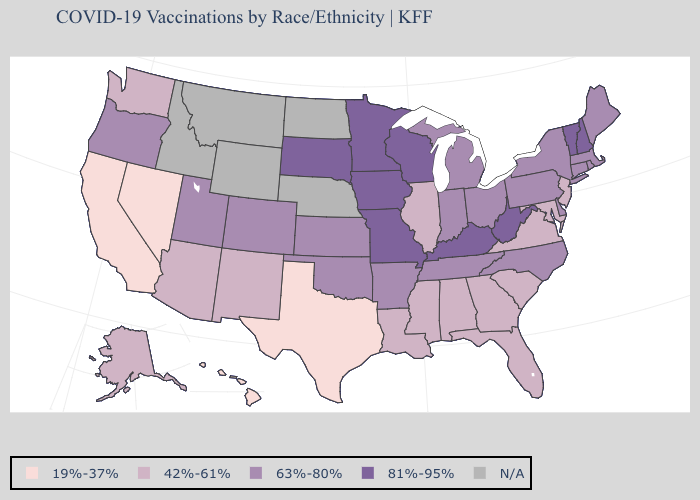Does Hawaii have the highest value in the USA?
Short answer required. No. Which states hav the highest value in the South?
Write a very short answer. Kentucky, West Virginia. Which states have the lowest value in the MidWest?
Keep it brief. Illinois. Name the states that have a value in the range N/A?
Write a very short answer. Idaho, Montana, Nebraska, North Dakota, Wyoming. Name the states that have a value in the range N/A?
Write a very short answer. Idaho, Montana, Nebraska, North Dakota, Wyoming. What is the highest value in states that border Oregon?
Quick response, please. 42%-61%. What is the value of Oklahoma?
Be succinct. 63%-80%. Name the states that have a value in the range 81%-95%?
Quick response, please. Iowa, Kentucky, Minnesota, Missouri, New Hampshire, South Dakota, Vermont, West Virginia, Wisconsin. Name the states that have a value in the range N/A?
Be succinct. Idaho, Montana, Nebraska, North Dakota, Wyoming. Does Arizona have the highest value in the West?
Concise answer only. No. What is the value of Kentucky?
Keep it brief. 81%-95%. Which states have the highest value in the USA?
Give a very brief answer. Iowa, Kentucky, Minnesota, Missouri, New Hampshire, South Dakota, Vermont, West Virginia, Wisconsin. Name the states that have a value in the range 63%-80%?
Answer briefly. Arkansas, Colorado, Connecticut, Delaware, Indiana, Kansas, Maine, Massachusetts, Michigan, New York, North Carolina, Ohio, Oklahoma, Oregon, Pennsylvania, Rhode Island, Tennessee, Utah. Name the states that have a value in the range 42%-61%?
Answer briefly. Alabama, Alaska, Arizona, Florida, Georgia, Illinois, Louisiana, Maryland, Mississippi, New Jersey, New Mexico, South Carolina, Virginia, Washington. Name the states that have a value in the range 19%-37%?
Concise answer only. California, Hawaii, Nevada, Texas. 